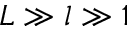Convert formula to latex. <formula><loc_0><loc_0><loc_500><loc_500>L \gg l \gg 1</formula> 